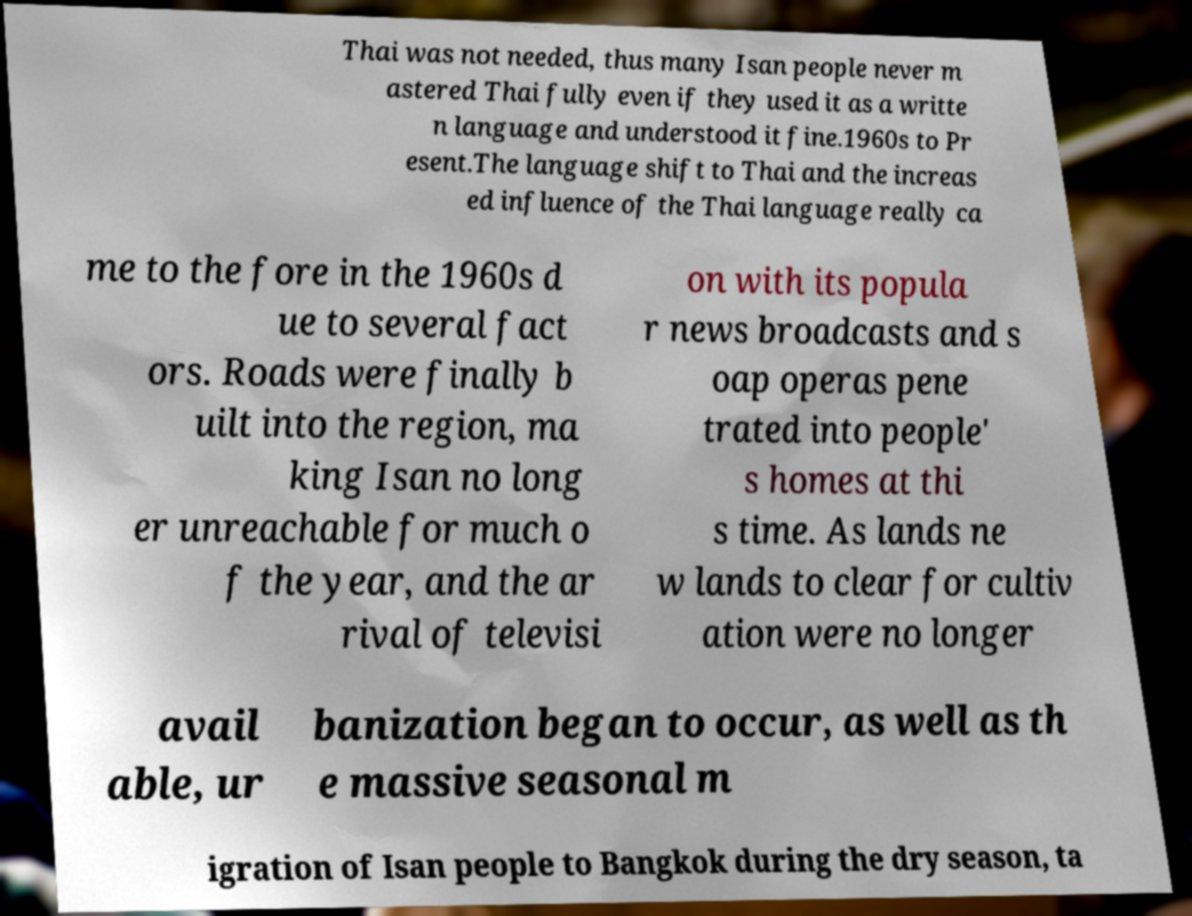For documentation purposes, I need the text within this image transcribed. Could you provide that? Thai was not needed, thus many Isan people never m astered Thai fully even if they used it as a writte n language and understood it fine.1960s to Pr esent.The language shift to Thai and the increas ed influence of the Thai language really ca me to the fore in the 1960s d ue to several fact ors. Roads were finally b uilt into the region, ma king Isan no long er unreachable for much o f the year, and the ar rival of televisi on with its popula r news broadcasts and s oap operas pene trated into people' s homes at thi s time. As lands ne w lands to clear for cultiv ation were no longer avail able, ur banization began to occur, as well as th e massive seasonal m igration of Isan people to Bangkok during the dry season, ta 